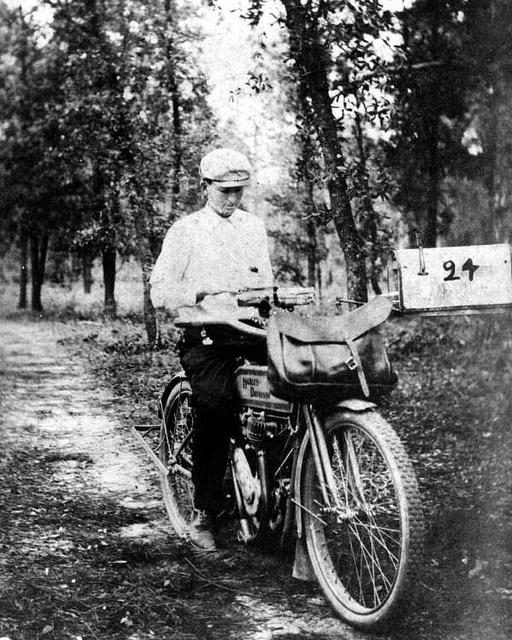Is that a bicycle?
Be succinct. Yes. What is the number on the mailbox?
Quick response, please. 24. What is this person wearing on head?
Concise answer only. Hat. 